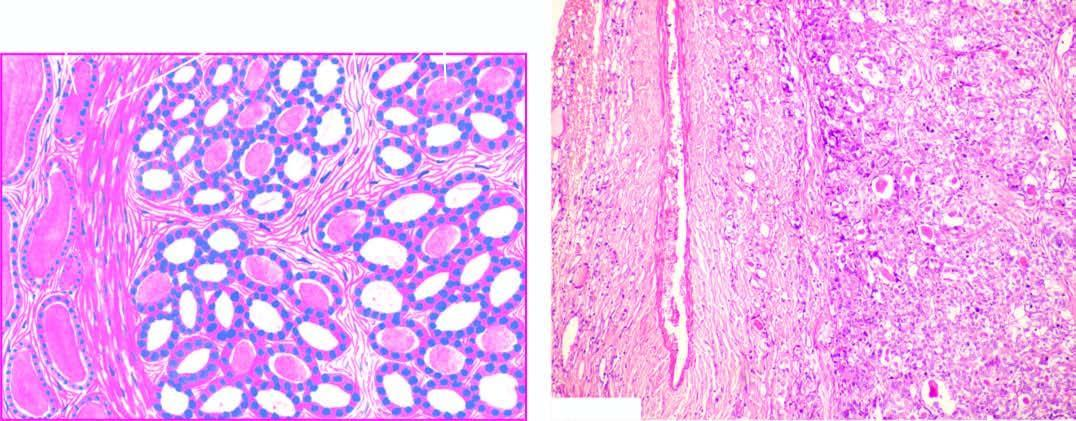s the wedge-shaped infarct well-encapsulated with compression of surrounding thyroid parenchyma?
Answer the question using a single word or phrase. No 